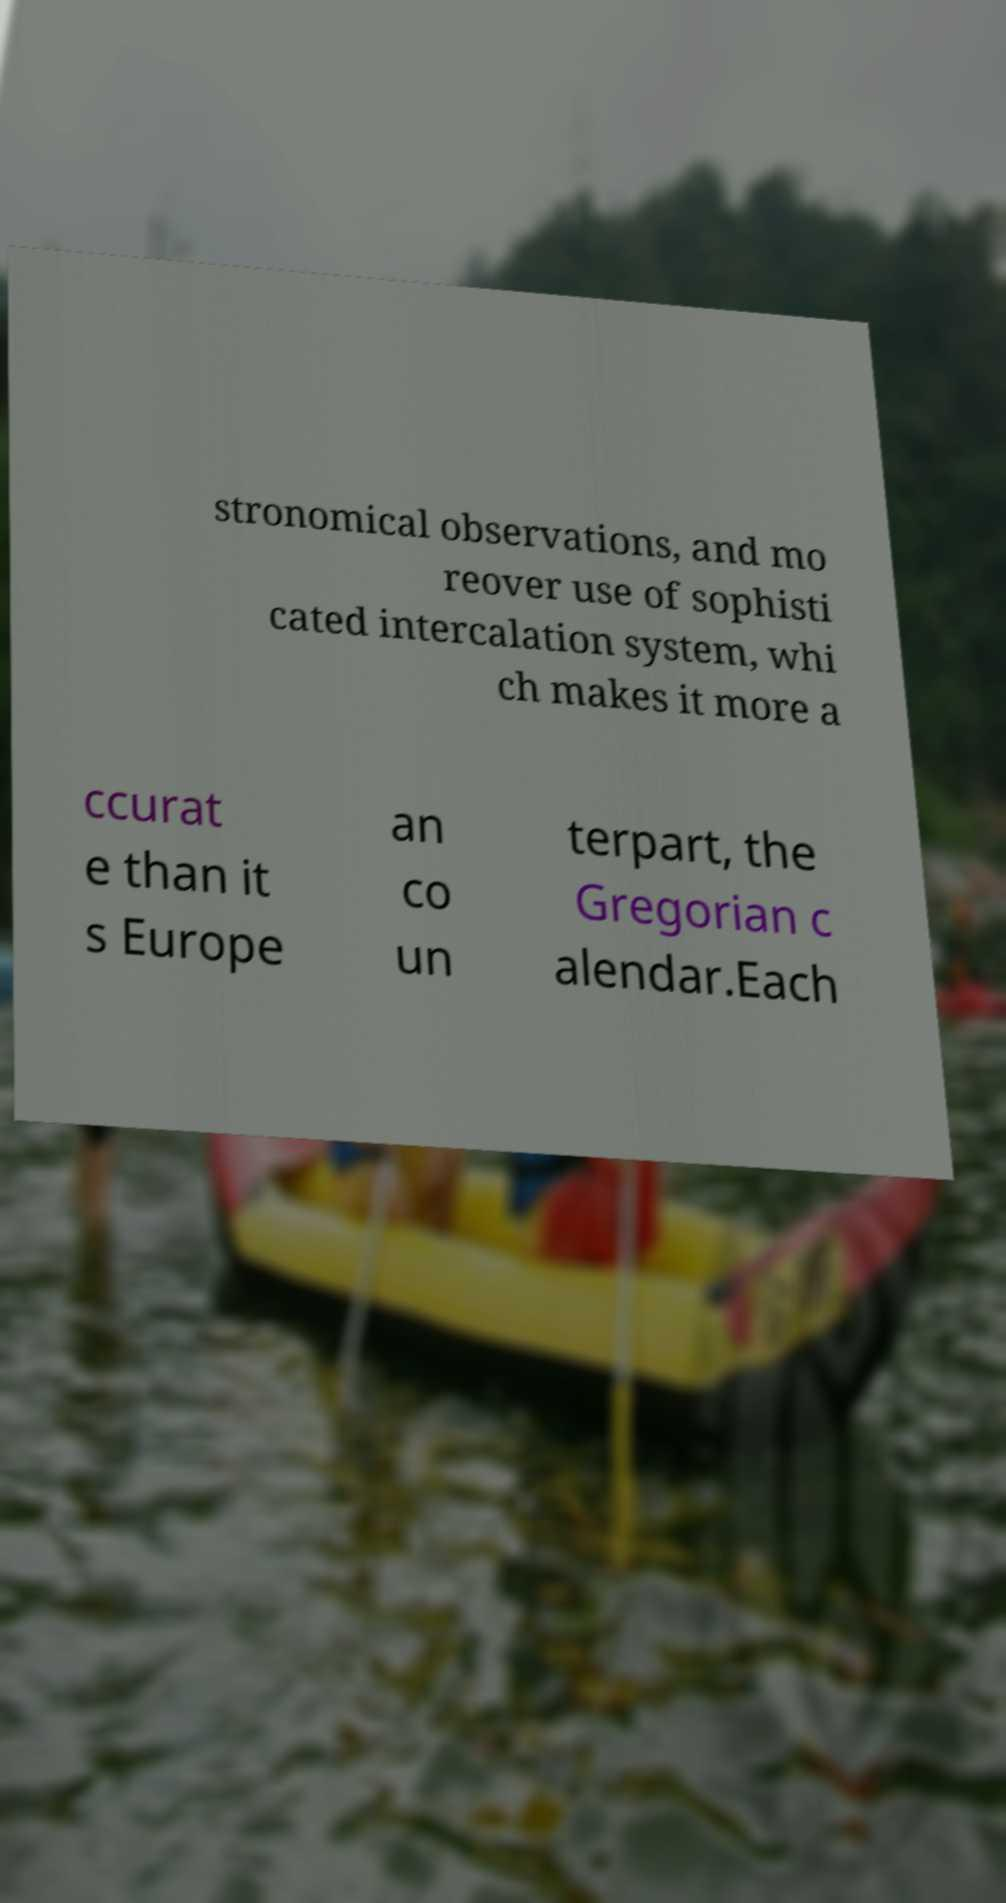Can you read and provide the text displayed in the image?This photo seems to have some interesting text. Can you extract and type it out for me? stronomical observations, and mo reover use of sophisti cated intercalation system, whi ch makes it more a ccurat e than it s Europe an co un terpart, the Gregorian c alendar.Each 